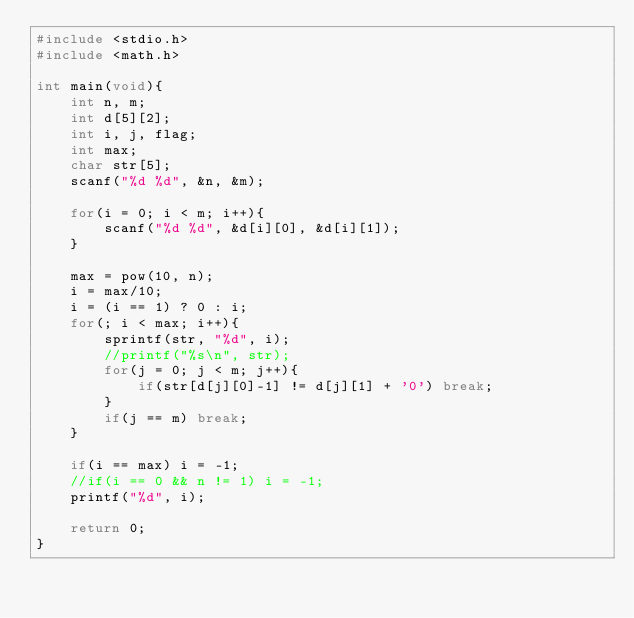Convert code to text. <code><loc_0><loc_0><loc_500><loc_500><_C_>#include <stdio.h>
#include <math.h>

int main(void){
    int n, m;
    int d[5][2];
    int i, j, flag;
    int max;
    char str[5];
    scanf("%d %d", &n, &m);
    
    for(i = 0; i < m; i++){
        scanf("%d %d", &d[i][0], &d[i][1]);
    }
    
    max = pow(10, n);
    i = max/10;
    i = (i == 1) ? 0 : i;
    for(; i < max; i++){
        sprintf(str, "%d", i);
        //printf("%s\n", str);
        for(j = 0; j < m; j++){
            if(str[d[j][0]-1] != d[j][1] + '0') break;
        }
        if(j == m) break;
    }
    
    if(i == max) i = -1;
    //if(i == 0 && n != 1) i = -1;
    printf("%d", i);
    
    return 0;
}
    </code> 